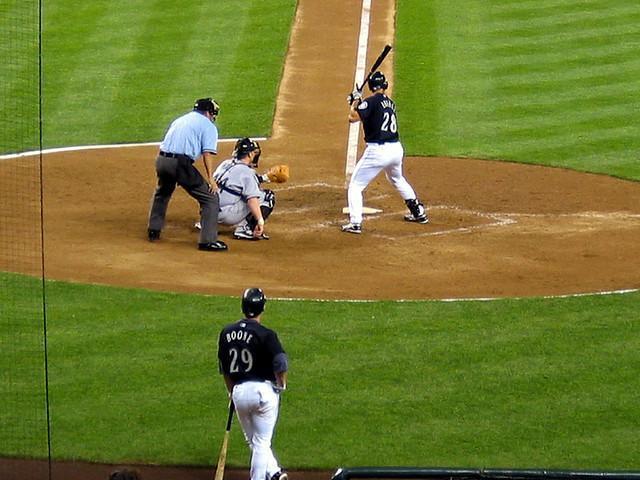How many players are there?
Give a very brief answer. 3. How many people are there?
Give a very brief answer. 4. How many people are on the elephant on the right?
Give a very brief answer. 0. 